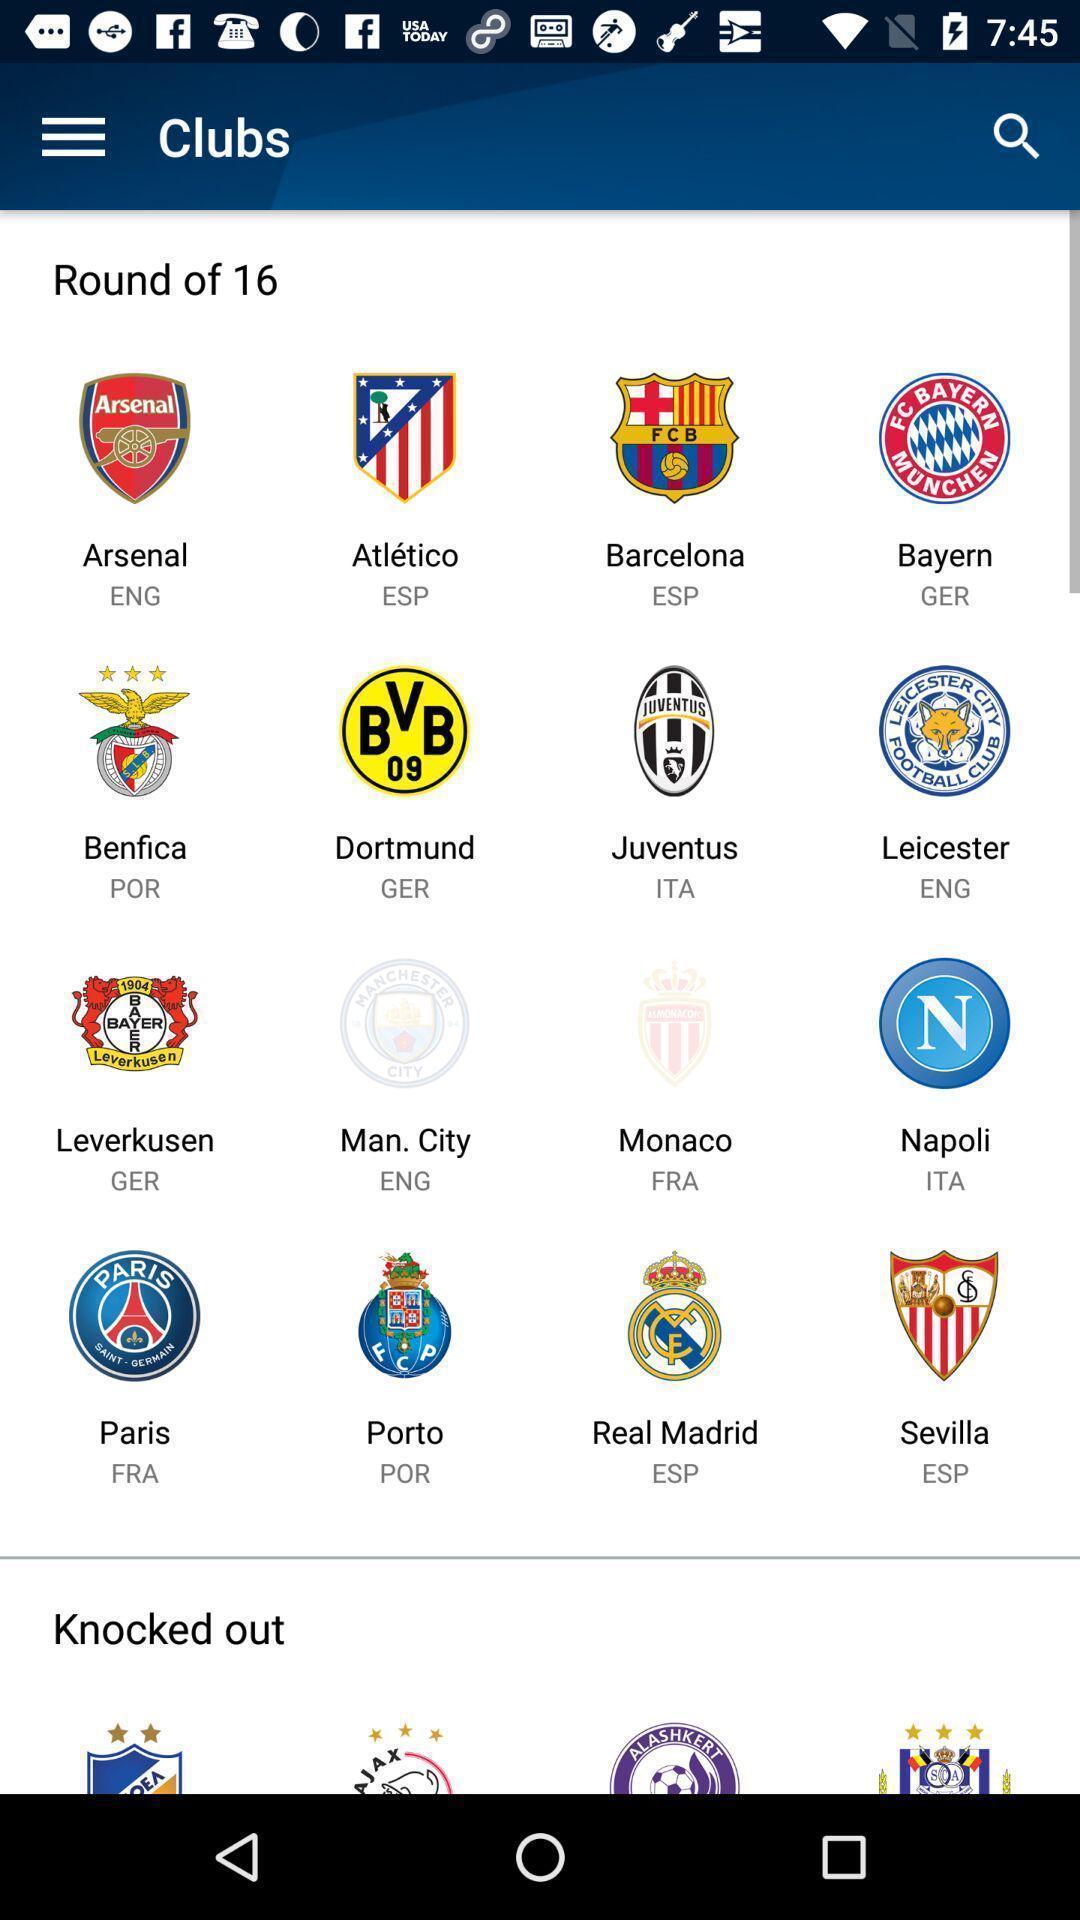Explain the elements present in this screenshot. Screen showing different sports groups logo. 